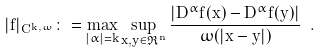Convert formula to latex. <formula><loc_0><loc_0><loc_500><loc_500>| f | _ { C ^ { k , \omega } } \colon = \max _ { | \alpha | = k } \sup _ { x , y \in \Re ^ { n } } \frac { | D ^ { \alpha } f ( x ) - D ^ { \alpha } f ( y ) | } { \omega ( | x - y | ) } \ .</formula> 